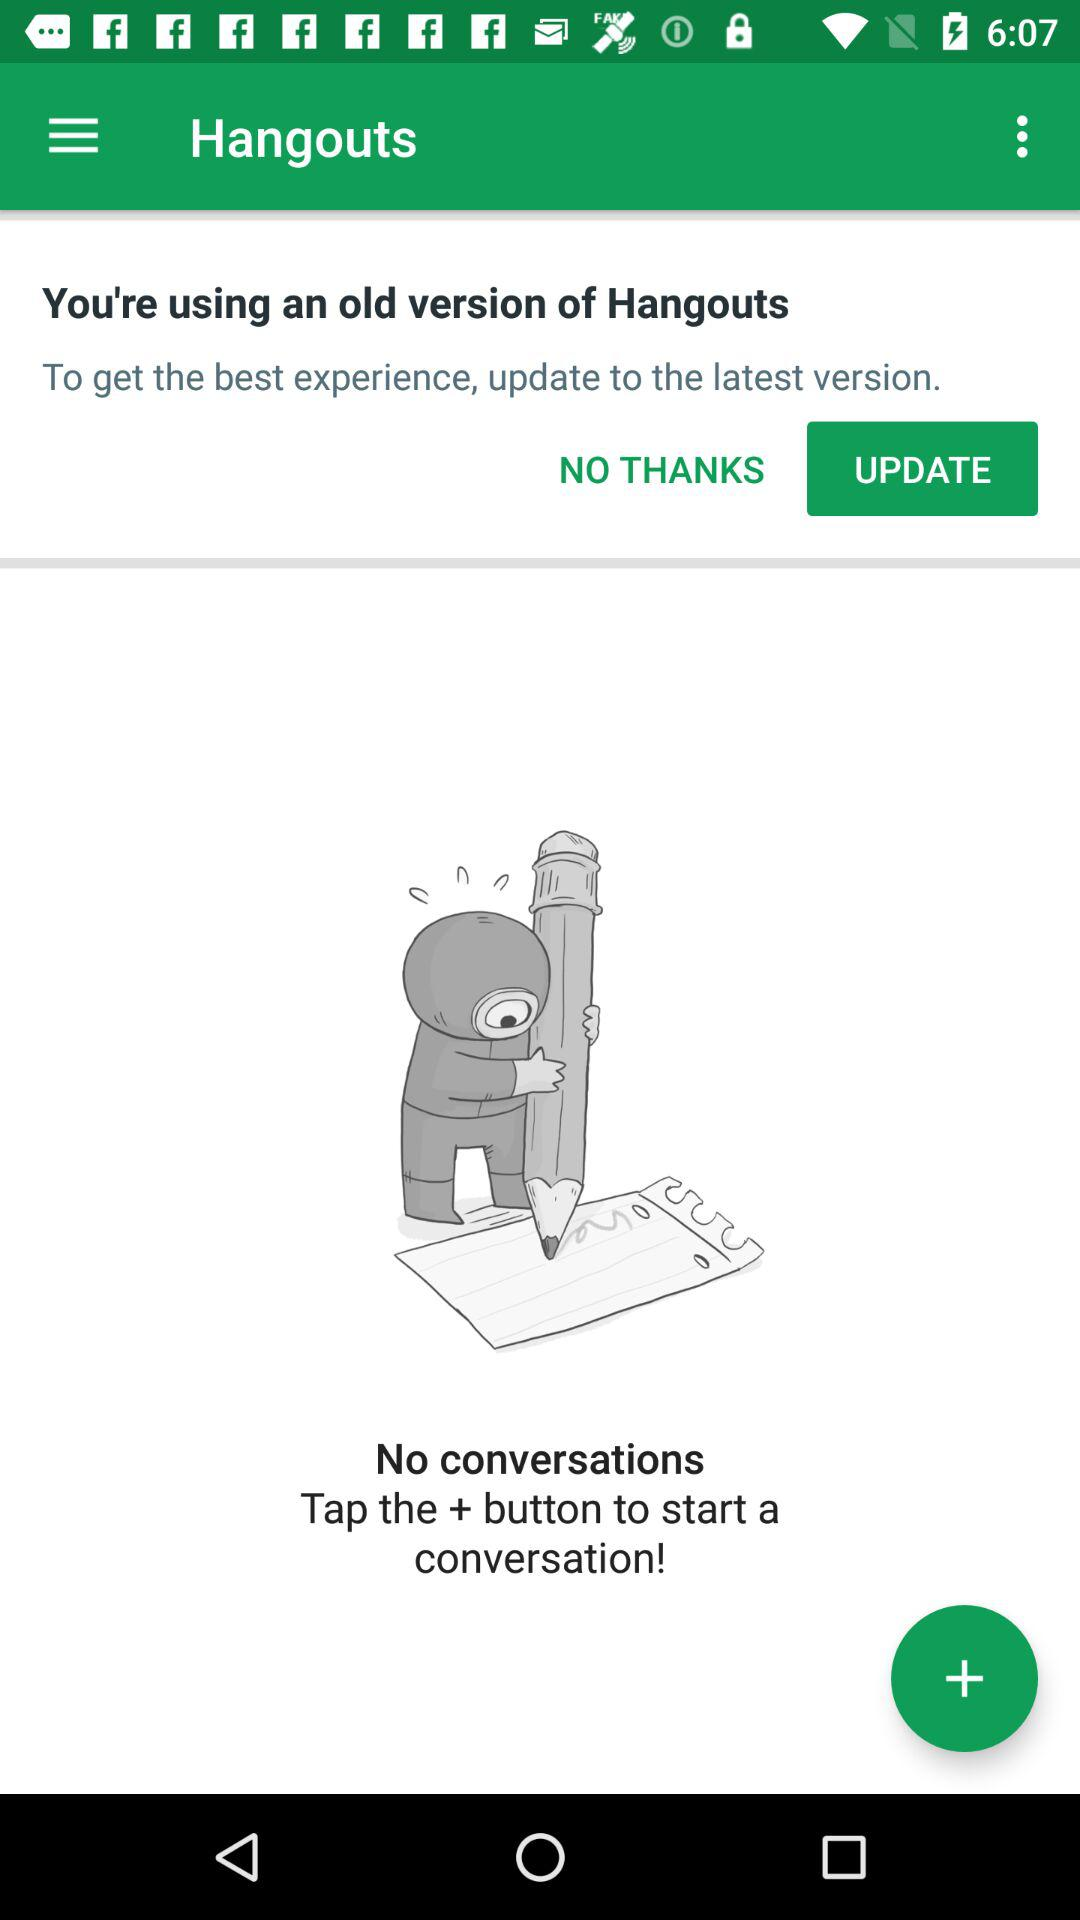What to do to start a new conversation? A new conversation can be started by tapping on the + button. 